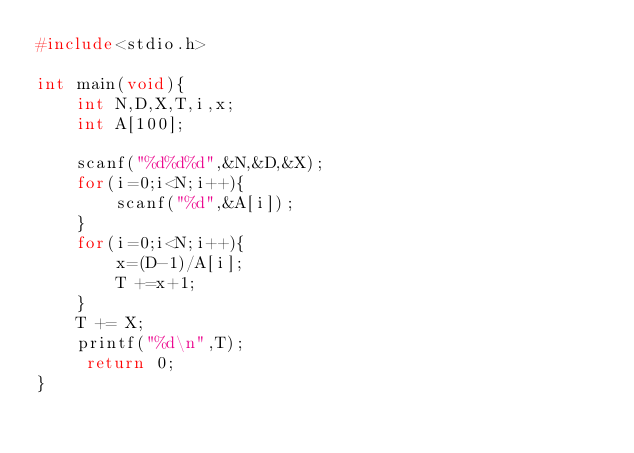<code> <loc_0><loc_0><loc_500><loc_500><_C_>#include<stdio.h>

int main(void){
    int N,D,X,T,i,x;
    int A[100];
    
    scanf("%d%d%d",&N,&D,&X);
    for(i=0;i<N;i++){
        scanf("%d",&A[i]);
    }
    for(i=0;i<N;i++){
        x=(D-1)/A[i];
        T +=x+1;
    }
    T += X;
    printf("%d\n",T);
     return 0;
}     </code> 